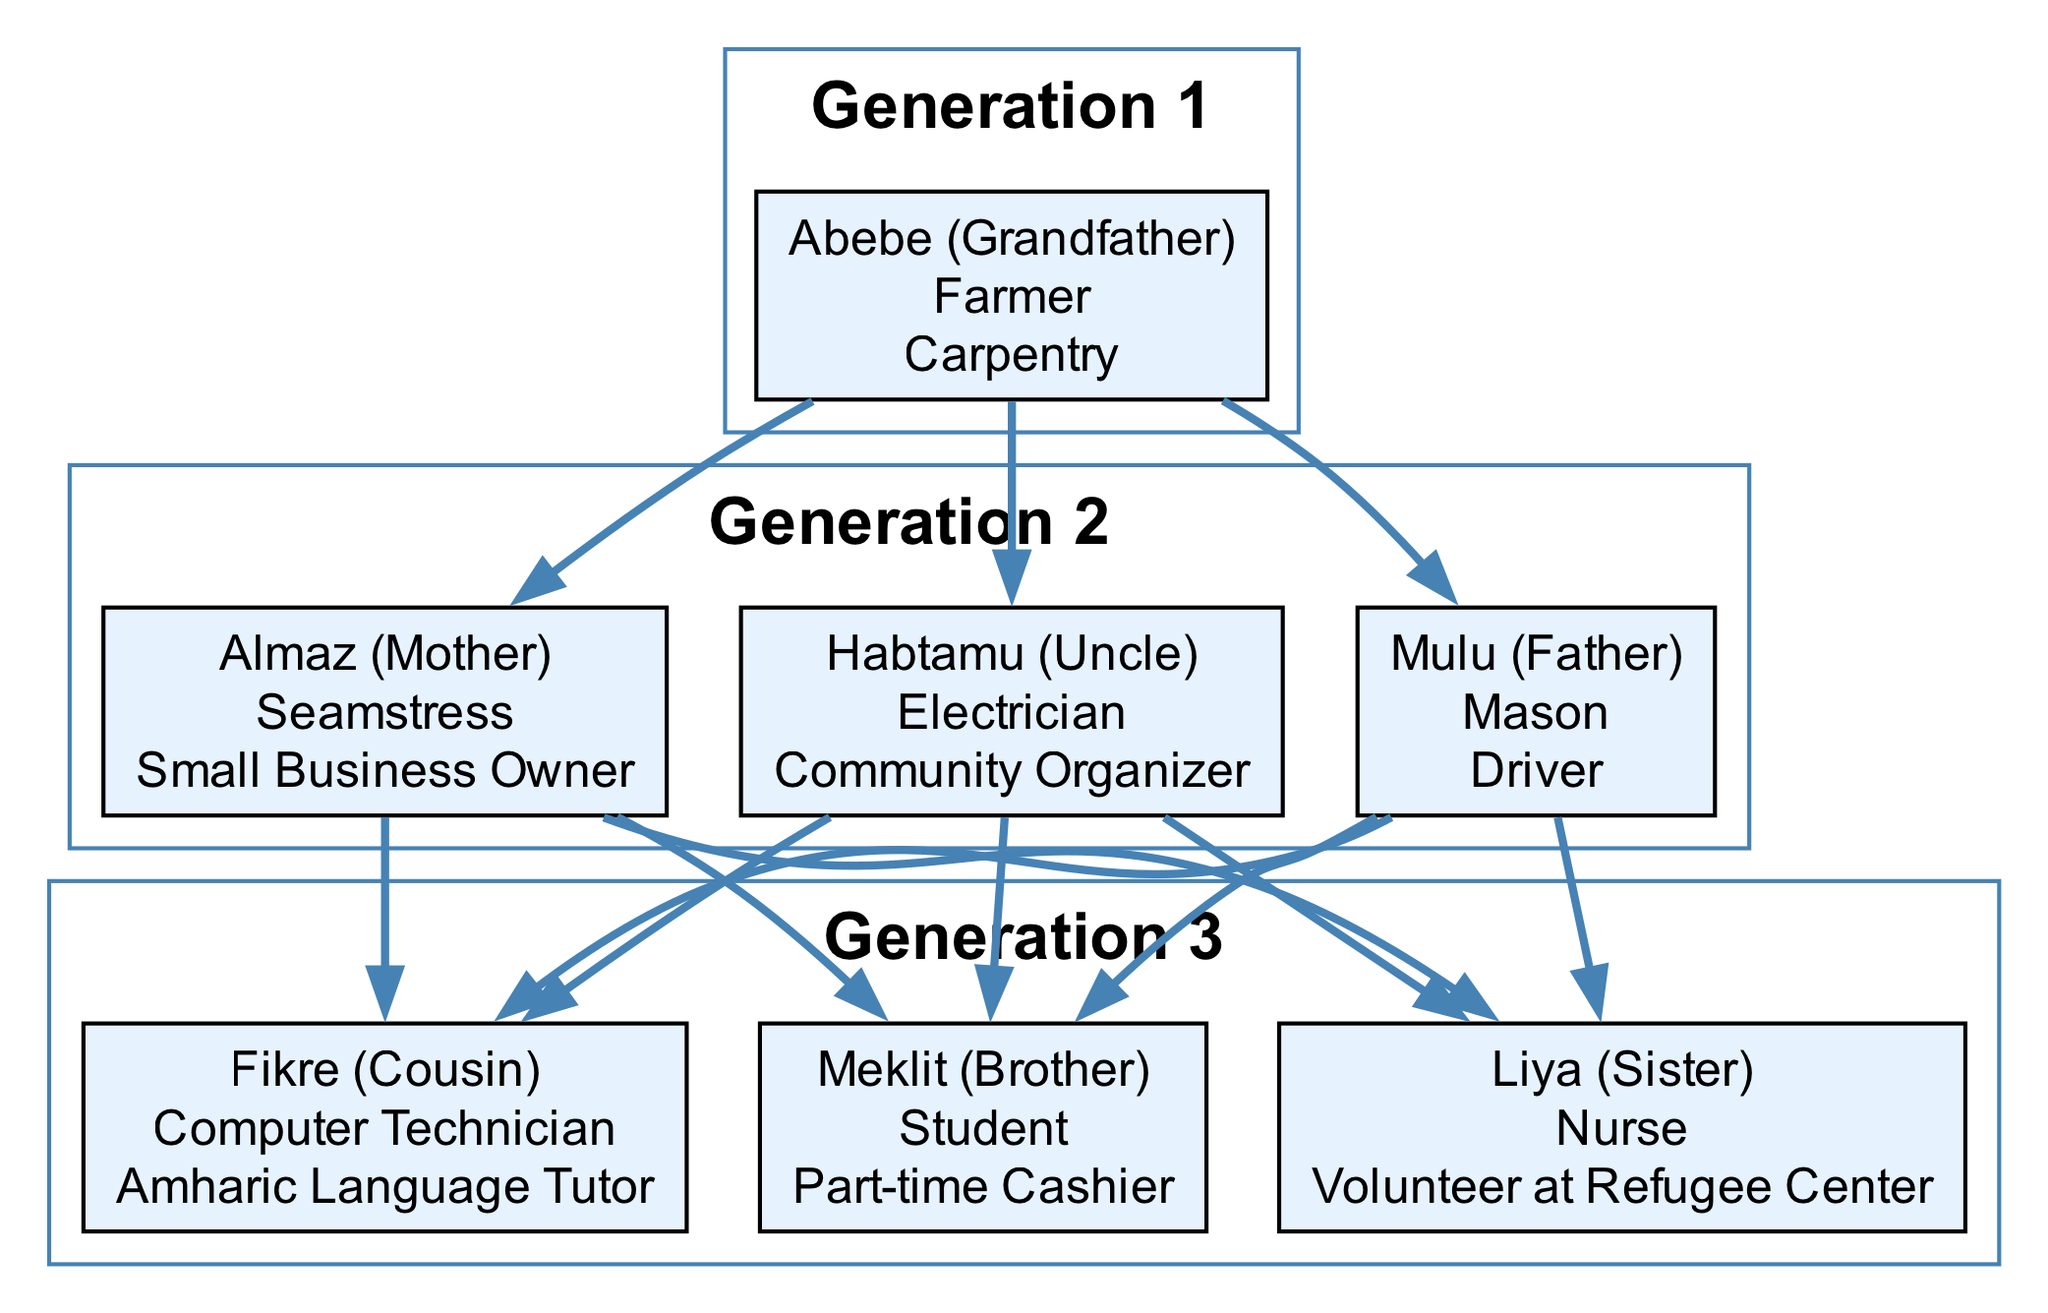What is the occupation of Abebe? Abebe is listed in the diagram as the grandfather, with the skills and occupations of "Farmer" and "Carpentry". Therefore, his primary occupations are specified directly under his name.
Answer: Farmer, Carpentry How many skills does Almaz have? Almaz, the mother, has two skills listed: "Seamstress" and "Small Business Owner". The diagram clearly outlines the skills associated with each family member, and Almaz's skills are directly visible.
Answer: 2 Who is Mulu's uncle? Mulu is identified as the father, and examining the relationships, Habtamu is listed as the uncle of Mulu. The diagram provides clear familial connections which help us identify the relationships directly.
Answer: Habtamu What is Liya's role in the family? Liya is portrayed in the diagram as the sister, with occupations listed as "Nurse" and "Volunteer at Refugee Center". This information highlights both her relationship and her professional roles within the family.
Answer: Sister Which generation does Habtamu belong to? Habtamu is listed in generation 2. By reviewing the structure of the diagram, we can clearly see that he is placed in the same generation as Mulu and Almaz, indicating they share the same parental generation.
Answer: Generation 2 How many siblings does Mulu have? Mulu has two siblings: Meklit (Brother) and Liya (Sister). The diagram allows us to visually count the connections stemming from Mulu, confirming that he has a brother and a sister.
Answer: 2 What skills does Fikre possess? Fikre is the cousin, and his skills listed are "Computer Technician" and "Amharic Language Tutor". By reviewing the information associated with Fikre in the diagram, we can identify his specific skillset.
Answer: Computer Technician, Amharic Language Tutor What is the relation between Mulu and Meklit? Mulu is identified as the father and Meklit is his brother, as per the diagram. Thus, the relationship is straightforward based on their placements in the family structure.
Answer: Father, Brother Name a skill that both Mulu and Almaz share. Mulu has skills as a "Mason" and "Driver", while Almaz is a "Seamstress" and "Small Business Owner". There are no shared skills noted, which indicates they have different sets of occupations. Therefore, there is no common skill.
Answer: None 